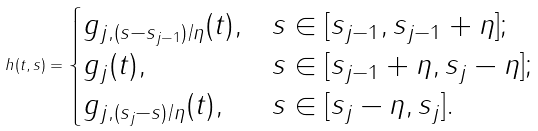<formula> <loc_0><loc_0><loc_500><loc_500>h ( t , s ) = \begin{cases} g _ { j , ( s - s _ { j - 1 } ) / \eta } ( t ) , & s \in [ s _ { j - 1 } , s _ { j - 1 } + \eta ] ; \\ g _ { j } ( t ) , & s \in [ s _ { j - 1 } + \eta , s _ { j } - \eta ] ; \\ g _ { j , ( s _ { j } - s ) / \eta } ( t ) , & s \in [ s _ { j } - \eta , s _ { j } ] . \end{cases}</formula> 